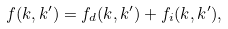Convert formula to latex. <formula><loc_0><loc_0><loc_500><loc_500>f ( k , k ^ { \prime } ) = f _ { d } ( k , k ^ { \prime } ) + f _ { i } ( k , k ^ { \prime } ) ,</formula> 